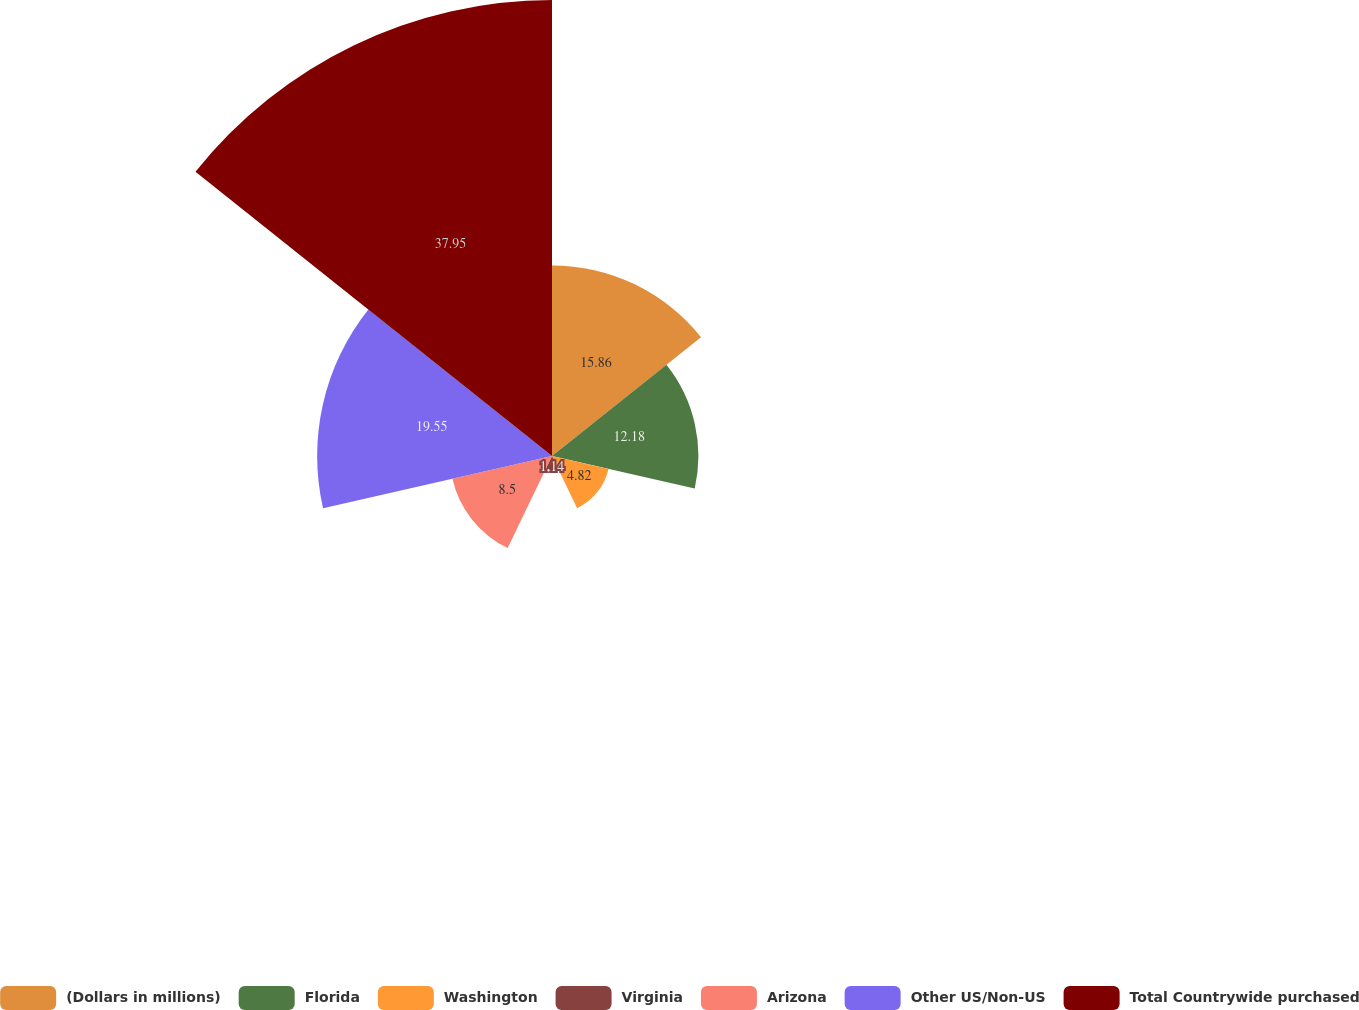<chart> <loc_0><loc_0><loc_500><loc_500><pie_chart><fcel>(Dollars in millions)<fcel>Florida<fcel>Washington<fcel>Virginia<fcel>Arizona<fcel>Other US/Non-US<fcel>Total Countrywide purchased<nl><fcel>15.86%<fcel>12.18%<fcel>4.82%<fcel>1.14%<fcel>8.5%<fcel>19.54%<fcel>37.94%<nl></chart> 